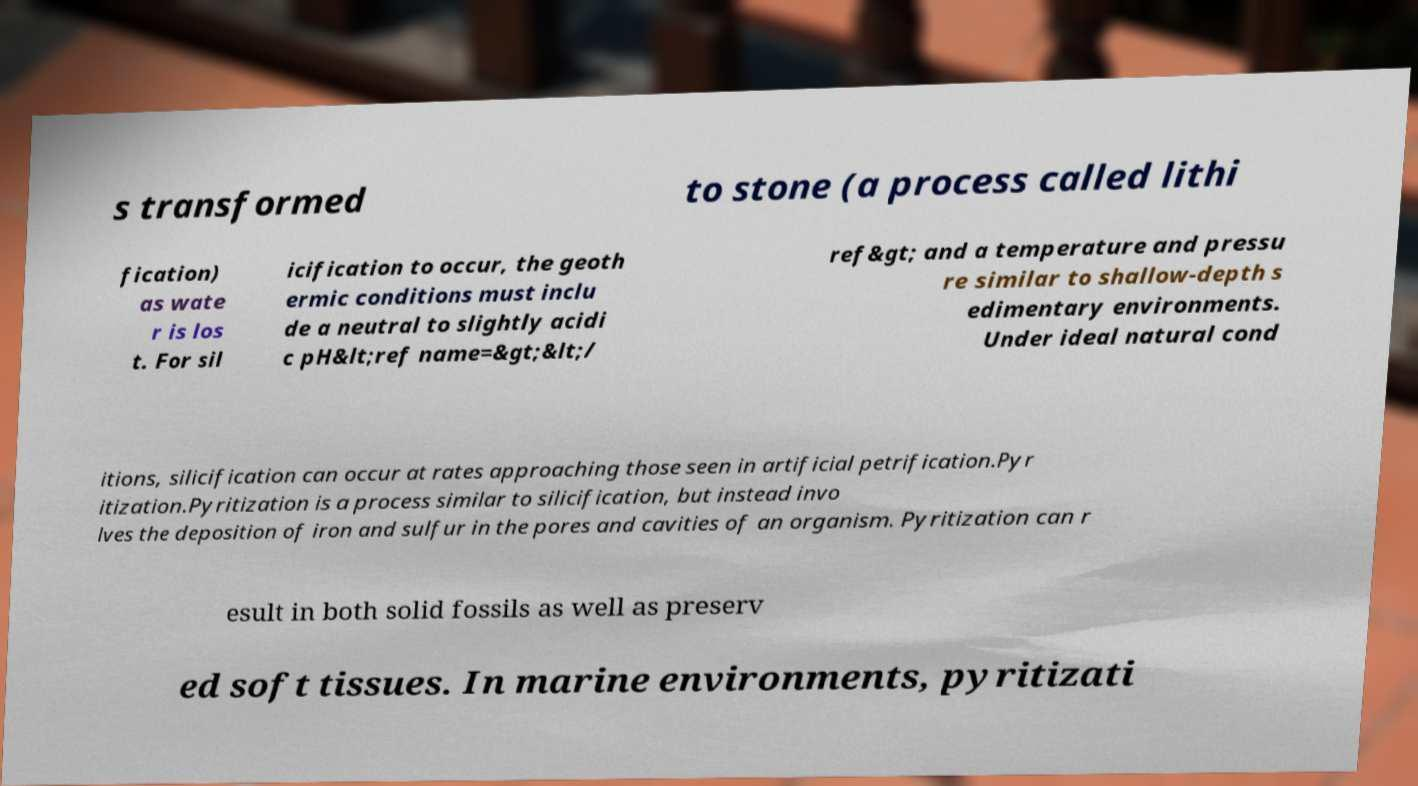For documentation purposes, I need the text within this image transcribed. Could you provide that? s transformed to stone (a process called lithi fication) as wate r is los t. For sil icification to occur, the geoth ermic conditions must inclu de a neutral to slightly acidi c pH&lt;ref name=&gt;&lt;/ ref&gt; and a temperature and pressu re similar to shallow-depth s edimentary environments. Under ideal natural cond itions, silicification can occur at rates approaching those seen in artificial petrification.Pyr itization.Pyritization is a process similar to silicification, but instead invo lves the deposition of iron and sulfur in the pores and cavities of an organism. Pyritization can r esult in both solid fossils as well as preserv ed soft tissues. In marine environments, pyritizati 